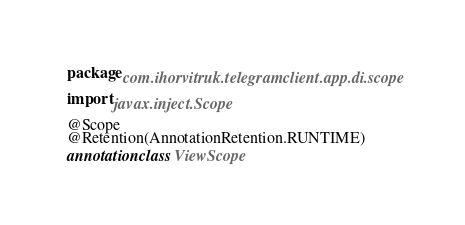Convert code to text. <code><loc_0><loc_0><loc_500><loc_500><_Kotlin_>package com.ihorvitruk.telegramclient.app.di.scope

import javax.inject.Scope

@Scope
@Retention(AnnotationRetention.RUNTIME)
annotation class ViewScope</code> 